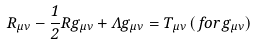<formula> <loc_0><loc_0><loc_500><loc_500>R _ { \mu \nu } - \frac { 1 } { 2 } R g _ { \mu \nu } + \Lambda g _ { \mu \nu } = T _ { \mu \nu } \, ( \, f o r \, g _ { \mu \nu } )</formula> 